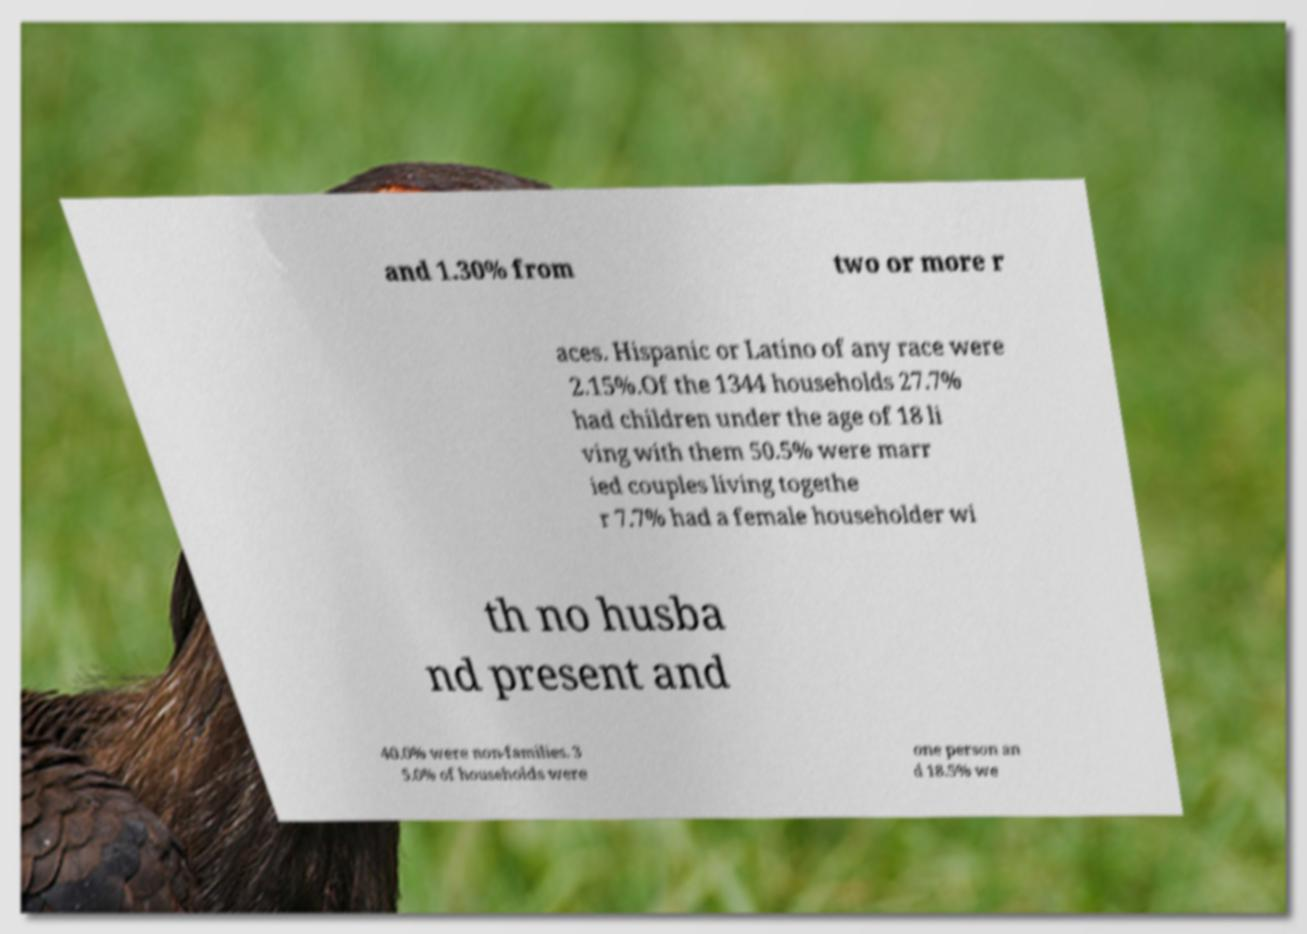Please read and relay the text visible in this image. What does it say? and 1.30% from two or more r aces. Hispanic or Latino of any race were 2.15%.Of the 1344 households 27.7% had children under the age of 18 li ving with them 50.5% were marr ied couples living togethe r 7.7% had a female householder wi th no husba nd present and 40.0% were non-families. 3 5.0% of households were one person an d 18.5% we 